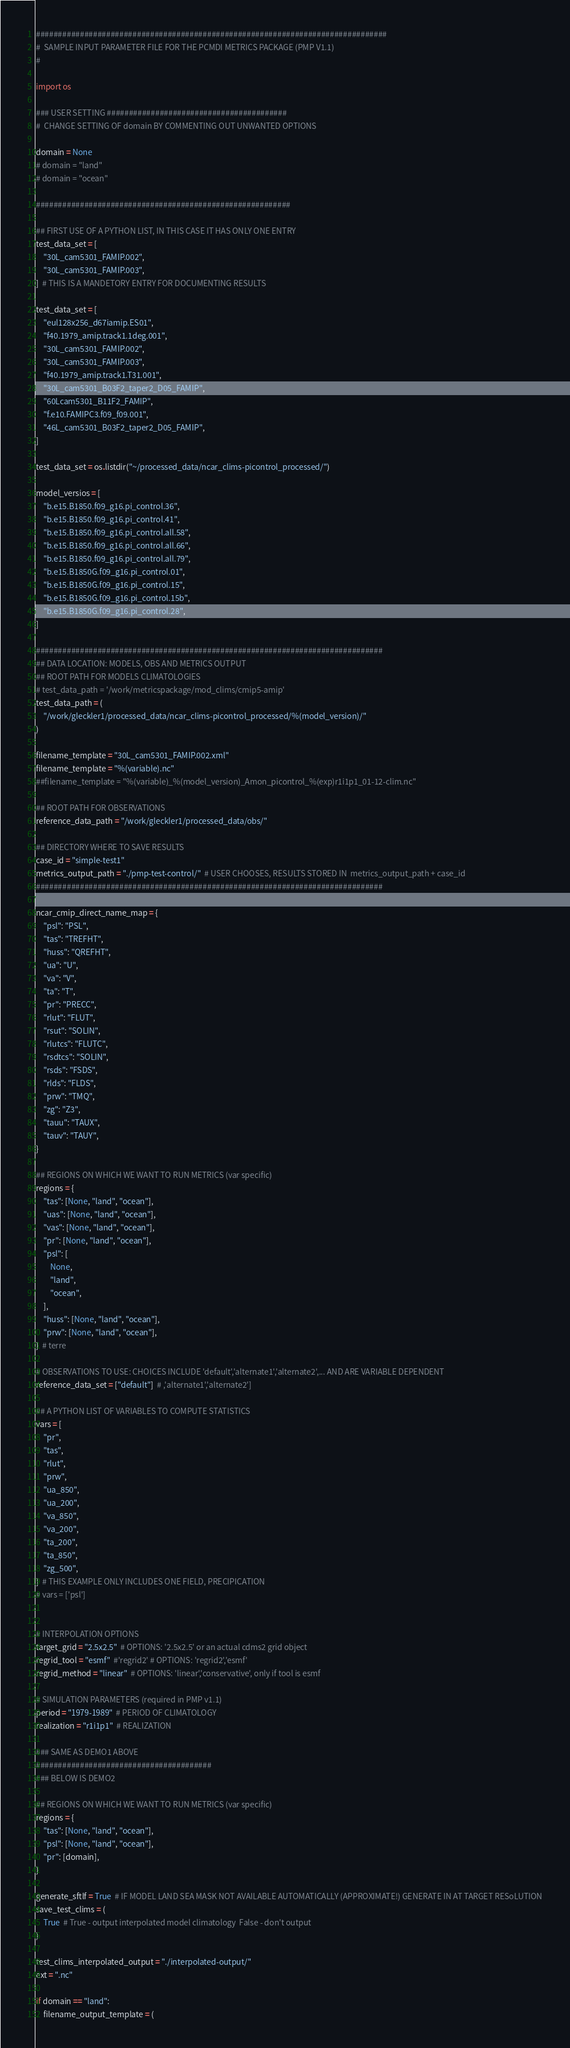<code> <loc_0><loc_0><loc_500><loc_500><_Python_>################################################################################
#  SAMPLE INPUT PARAMETER FILE FOR THE PCMDI METRICS PACKAGE (PMP V1.1)
#

import os

### USER SETTING #########################################
#  CHANGE SETTING OF domain BY COMMENTING OUT UNWANTED OPTIONS

domain = None
# domain = "land"
# domain = "ocean"

##########################################################

## FIRST USE OF A PYTHON LIST, IN THIS CASE IT HAS ONLY ONE ENTRY
test_data_set = [
    "30L_cam5301_FAMIP.002",
    "30L_cam5301_FAMIP.003",
]  # THIS IS A MANDETORY ENTRY FOR DOCUMENTING RESULTS

test_data_set = [
    "eul128x256_d67iamip.ES01",
    "f40.1979_amip.track1.1deg.001",
    "30L_cam5301_FAMIP.002",
    "30L_cam5301_FAMIP.003",
    "f40.1979_amip.track1.T31.001",
    "30L_cam5301_B03F2_taper2_D05_FAMIP",
    "60Lcam5301_B11F2_FAMIP",
    "f.e10.FAMIPC3.f09_f09.001",
    "46L_cam5301_B03F2_taper2_D05_FAMIP",
]

test_data_set = os.listdir("~/processed_data/ncar_clims-picontrol_processed/")

model_versios = [
    "b.e15.B1850.f09_g16.pi_control.36",
    "b.e15.B1850.f09_g16.pi_control.41",
    "b.e15.B1850.f09_g16.pi_control.all.58",
    "b.e15.B1850.f09_g16.pi_control.all.66",
    "b.e15.B1850.f09_g16.pi_control.all.79",
    "b.e15.B1850G.f09_g16.pi_control.01",
    "b.e15.B1850G.f09_g16.pi_control.15",
    "b.e15.B1850G.f09_g16.pi_control.15b",
    "b.e15.B1850G.f09_g16.pi_control.28",
]

###############################################################################
## DATA LOCATION: MODELS, OBS AND METRICS OUTPUT
## ROOT PATH FOR MODELS CLIMATOLOGIES
# test_data_path = '/work/metricspackage/mod_clims/cmip5-amip'
test_data_path = (
    "/work/gleckler1/processed_data/ncar_clims-picontrol_processed/%(model_version)/"
)

filename_template = "30L_cam5301_FAMIP.002.xml"
filename_template = "%(variable).nc"
##filename_template = "%(variable)_%(model_version)_Amon_picontrol_%(exp)r1i1p1_01-12-clim.nc"

## ROOT PATH FOR OBSERVATIONS
reference_data_path = "/work/gleckler1/processed_data/obs/"

## DIRECTORY WHERE TO SAVE RESULTS
case_id = "simple-test1"
metrics_output_path = "./pmp-test-control/"  # USER CHOOSES, RESULTS STORED IN  metrics_output_path + case_id
###############################################################################

ncar_cmip_direct_name_map = {
    "psl": "PSL",
    "tas": "TREFHT",
    "huss": "QREFHT",
    "ua": "U",
    "va": "V",
    "ta": "T",
    "pr": "PRECC",
    "rlut": "FLUT",
    "rsut": "SOLIN",
    "rlutcs": "FLUTC",
    "rsdtcs": "SOLIN",
    "rsds": "FSDS",
    "rlds": "FLDS",
    "prw": "TMQ",
    "zg": "Z3",
    "tauu": "TAUX",
    "tauv": "TAUY",
}

## REGIONS ON WHICH WE WANT TO RUN METRICS (var specific)
regions = {
    "tas": [None, "land", "ocean"],
    "uas": [None, "land", "ocean"],
    "vas": [None, "land", "ocean"],
    "pr": [None, "land", "ocean"],
    "psl": [
        None,
        "land",
        "ocean",
    ],
    "huss": [None, "land", "ocean"],
    "prw": [None, "land", "ocean"],
}  # terre

# OBSERVATIONS TO USE: CHOICES INCLUDE 'default','alternate1','alternate2',... AND ARE VARIABLE DEPENDENT
reference_data_set = ["default"]  # ,'alternate1','alternate2']

## A PYTHON LIST OF VARIABLES TO COMPUTE STATISTICS
vars = [
    "pr",
    "tas",
    "rlut",
    "prw",
    "ua_850",
    "ua_200",
    "va_850",
    "va_200",
    "ta_200",
    "ta_850",
    "zg_500",
]  # THIS EXAMPLE ONLY INCLUDES ONE FIELD, PRECIPICATION
# vars = ['psl']


# INTERPOLATION OPTIONS
target_grid = "2.5x2.5"  # OPTIONS: '2.5x2.5' or an actual cdms2 grid object
regrid_tool = "esmf"  #'regrid2' # OPTIONS: 'regrid2','esmf'
regrid_method = "linear"  # OPTIONS: 'linear','conservative', only if tool is esmf

# SIMULATION PARAMETERS (required in PMP v1.1)
period = "1979-1989"  # PERIOD OF CLIMATOLOGY
realization = "r1i1p1"  # REALIZATION

### SAME AS DEMO1 ABOVE
########################################
### BELOW IS DEMO2

## REGIONS ON WHICH WE WANT TO RUN METRICS (var specific)
regions = {
    "tas": [None, "land", "ocean"],
    "psl": [None, "land", "ocean"],
    "pr": [domain],
}

generate_sftlf = True  # IF MODEL LAND SEA MASK NOT AVAILABLE AUTOMATICALLY (APPROXIMATE!) GENERATE IN AT TARGET RESoLUTION
save_test_clims = (
    True  # True - output interpolated model climatology  False - don't output
)

test_clims_interpolated_output = "./interpolated-output/"
ext = ".nc"

if domain == "land":
    filename_output_template = (</code> 